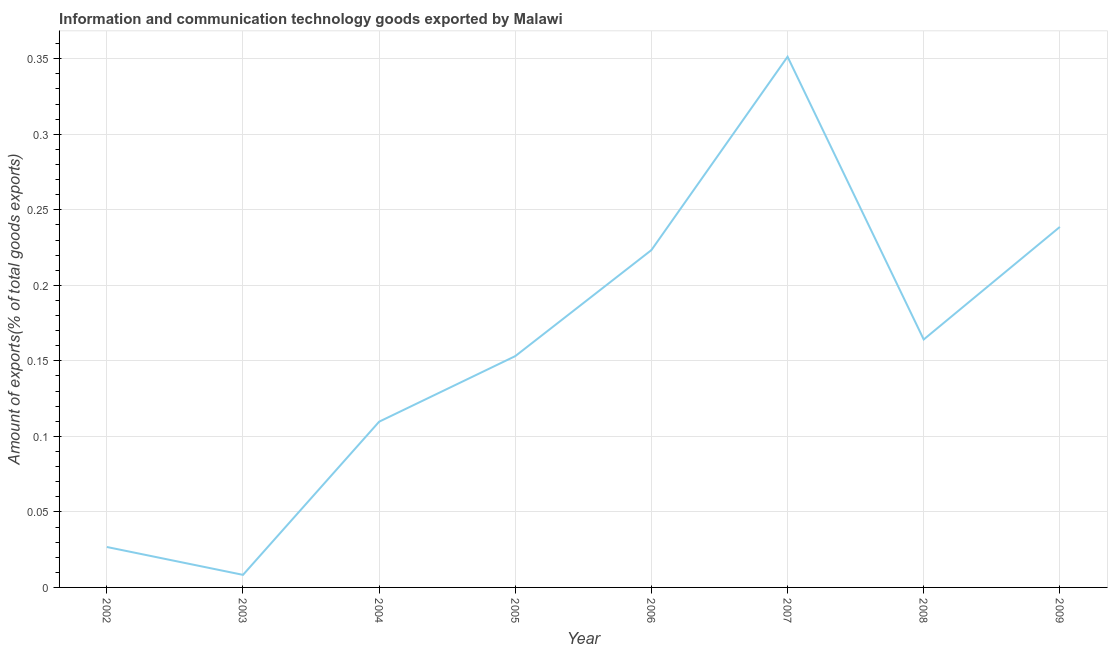What is the amount of ict goods exports in 2006?
Ensure brevity in your answer.  0.22. Across all years, what is the maximum amount of ict goods exports?
Ensure brevity in your answer.  0.35. Across all years, what is the minimum amount of ict goods exports?
Offer a terse response. 0.01. In which year was the amount of ict goods exports minimum?
Ensure brevity in your answer.  2003. What is the sum of the amount of ict goods exports?
Keep it short and to the point. 1.28. What is the difference between the amount of ict goods exports in 2006 and 2009?
Your answer should be compact. -0.02. What is the average amount of ict goods exports per year?
Make the answer very short. 0.16. What is the median amount of ict goods exports?
Provide a succinct answer. 0.16. In how many years, is the amount of ict goods exports greater than 0.16000000000000003 %?
Give a very brief answer. 4. What is the ratio of the amount of ict goods exports in 2006 to that in 2007?
Provide a short and direct response. 0.64. What is the difference between the highest and the second highest amount of ict goods exports?
Keep it short and to the point. 0.11. Is the sum of the amount of ict goods exports in 2004 and 2005 greater than the maximum amount of ict goods exports across all years?
Your answer should be compact. No. What is the difference between the highest and the lowest amount of ict goods exports?
Provide a succinct answer. 0.34. How many lines are there?
Ensure brevity in your answer.  1. How many years are there in the graph?
Make the answer very short. 8. What is the difference between two consecutive major ticks on the Y-axis?
Ensure brevity in your answer.  0.05. Does the graph contain grids?
Your response must be concise. Yes. What is the title of the graph?
Keep it short and to the point. Information and communication technology goods exported by Malawi. What is the label or title of the Y-axis?
Provide a short and direct response. Amount of exports(% of total goods exports). What is the Amount of exports(% of total goods exports) of 2002?
Your response must be concise. 0.03. What is the Amount of exports(% of total goods exports) of 2003?
Offer a terse response. 0.01. What is the Amount of exports(% of total goods exports) of 2004?
Keep it short and to the point. 0.11. What is the Amount of exports(% of total goods exports) of 2005?
Offer a terse response. 0.15. What is the Amount of exports(% of total goods exports) of 2006?
Your answer should be very brief. 0.22. What is the Amount of exports(% of total goods exports) of 2007?
Offer a very short reply. 0.35. What is the Amount of exports(% of total goods exports) in 2008?
Provide a succinct answer. 0.16. What is the Amount of exports(% of total goods exports) of 2009?
Your response must be concise. 0.24. What is the difference between the Amount of exports(% of total goods exports) in 2002 and 2003?
Make the answer very short. 0.02. What is the difference between the Amount of exports(% of total goods exports) in 2002 and 2004?
Your answer should be compact. -0.08. What is the difference between the Amount of exports(% of total goods exports) in 2002 and 2005?
Your answer should be compact. -0.13. What is the difference between the Amount of exports(% of total goods exports) in 2002 and 2006?
Ensure brevity in your answer.  -0.2. What is the difference between the Amount of exports(% of total goods exports) in 2002 and 2007?
Keep it short and to the point. -0.32. What is the difference between the Amount of exports(% of total goods exports) in 2002 and 2008?
Offer a very short reply. -0.14. What is the difference between the Amount of exports(% of total goods exports) in 2002 and 2009?
Your answer should be very brief. -0.21. What is the difference between the Amount of exports(% of total goods exports) in 2003 and 2004?
Give a very brief answer. -0.1. What is the difference between the Amount of exports(% of total goods exports) in 2003 and 2005?
Ensure brevity in your answer.  -0.14. What is the difference between the Amount of exports(% of total goods exports) in 2003 and 2006?
Give a very brief answer. -0.22. What is the difference between the Amount of exports(% of total goods exports) in 2003 and 2007?
Make the answer very short. -0.34. What is the difference between the Amount of exports(% of total goods exports) in 2003 and 2008?
Keep it short and to the point. -0.16. What is the difference between the Amount of exports(% of total goods exports) in 2003 and 2009?
Keep it short and to the point. -0.23. What is the difference between the Amount of exports(% of total goods exports) in 2004 and 2005?
Ensure brevity in your answer.  -0.04. What is the difference between the Amount of exports(% of total goods exports) in 2004 and 2006?
Your answer should be very brief. -0.11. What is the difference between the Amount of exports(% of total goods exports) in 2004 and 2007?
Your response must be concise. -0.24. What is the difference between the Amount of exports(% of total goods exports) in 2004 and 2008?
Offer a very short reply. -0.05. What is the difference between the Amount of exports(% of total goods exports) in 2004 and 2009?
Provide a short and direct response. -0.13. What is the difference between the Amount of exports(% of total goods exports) in 2005 and 2006?
Your answer should be very brief. -0.07. What is the difference between the Amount of exports(% of total goods exports) in 2005 and 2007?
Offer a very short reply. -0.2. What is the difference between the Amount of exports(% of total goods exports) in 2005 and 2008?
Your answer should be very brief. -0.01. What is the difference between the Amount of exports(% of total goods exports) in 2005 and 2009?
Make the answer very short. -0.09. What is the difference between the Amount of exports(% of total goods exports) in 2006 and 2007?
Offer a terse response. -0.13. What is the difference between the Amount of exports(% of total goods exports) in 2006 and 2008?
Give a very brief answer. 0.06. What is the difference between the Amount of exports(% of total goods exports) in 2006 and 2009?
Offer a very short reply. -0.02. What is the difference between the Amount of exports(% of total goods exports) in 2007 and 2008?
Offer a terse response. 0.19. What is the difference between the Amount of exports(% of total goods exports) in 2007 and 2009?
Ensure brevity in your answer.  0.11. What is the difference between the Amount of exports(% of total goods exports) in 2008 and 2009?
Ensure brevity in your answer.  -0.07. What is the ratio of the Amount of exports(% of total goods exports) in 2002 to that in 2003?
Your answer should be very brief. 3.22. What is the ratio of the Amount of exports(% of total goods exports) in 2002 to that in 2004?
Provide a short and direct response. 0.24. What is the ratio of the Amount of exports(% of total goods exports) in 2002 to that in 2005?
Keep it short and to the point. 0.17. What is the ratio of the Amount of exports(% of total goods exports) in 2002 to that in 2006?
Your answer should be compact. 0.12. What is the ratio of the Amount of exports(% of total goods exports) in 2002 to that in 2007?
Offer a terse response. 0.08. What is the ratio of the Amount of exports(% of total goods exports) in 2002 to that in 2008?
Your answer should be very brief. 0.16. What is the ratio of the Amount of exports(% of total goods exports) in 2002 to that in 2009?
Provide a short and direct response. 0.11. What is the ratio of the Amount of exports(% of total goods exports) in 2003 to that in 2004?
Make the answer very short. 0.08. What is the ratio of the Amount of exports(% of total goods exports) in 2003 to that in 2005?
Your answer should be compact. 0.05. What is the ratio of the Amount of exports(% of total goods exports) in 2003 to that in 2006?
Your answer should be very brief. 0.04. What is the ratio of the Amount of exports(% of total goods exports) in 2003 to that in 2007?
Ensure brevity in your answer.  0.02. What is the ratio of the Amount of exports(% of total goods exports) in 2003 to that in 2008?
Offer a very short reply. 0.05. What is the ratio of the Amount of exports(% of total goods exports) in 2003 to that in 2009?
Offer a terse response. 0.04. What is the ratio of the Amount of exports(% of total goods exports) in 2004 to that in 2005?
Make the answer very short. 0.72. What is the ratio of the Amount of exports(% of total goods exports) in 2004 to that in 2006?
Offer a very short reply. 0.49. What is the ratio of the Amount of exports(% of total goods exports) in 2004 to that in 2007?
Keep it short and to the point. 0.31. What is the ratio of the Amount of exports(% of total goods exports) in 2004 to that in 2008?
Ensure brevity in your answer.  0.67. What is the ratio of the Amount of exports(% of total goods exports) in 2004 to that in 2009?
Your response must be concise. 0.46. What is the ratio of the Amount of exports(% of total goods exports) in 2005 to that in 2006?
Ensure brevity in your answer.  0.69. What is the ratio of the Amount of exports(% of total goods exports) in 2005 to that in 2007?
Your answer should be very brief. 0.44. What is the ratio of the Amount of exports(% of total goods exports) in 2005 to that in 2008?
Make the answer very short. 0.93. What is the ratio of the Amount of exports(% of total goods exports) in 2005 to that in 2009?
Provide a succinct answer. 0.64. What is the ratio of the Amount of exports(% of total goods exports) in 2006 to that in 2007?
Your answer should be compact. 0.64. What is the ratio of the Amount of exports(% of total goods exports) in 2006 to that in 2008?
Your response must be concise. 1.36. What is the ratio of the Amount of exports(% of total goods exports) in 2006 to that in 2009?
Your answer should be very brief. 0.94. What is the ratio of the Amount of exports(% of total goods exports) in 2007 to that in 2008?
Make the answer very short. 2.14. What is the ratio of the Amount of exports(% of total goods exports) in 2007 to that in 2009?
Offer a terse response. 1.47. What is the ratio of the Amount of exports(% of total goods exports) in 2008 to that in 2009?
Your answer should be very brief. 0.69. 